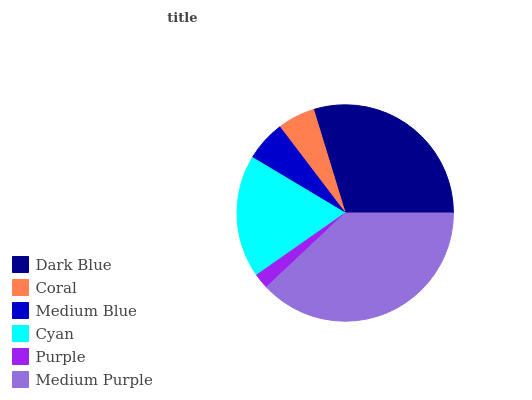Is Purple the minimum?
Answer yes or no. Yes. Is Medium Purple the maximum?
Answer yes or no. Yes. Is Coral the minimum?
Answer yes or no. No. Is Coral the maximum?
Answer yes or no. No. Is Dark Blue greater than Coral?
Answer yes or no. Yes. Is Coral less than Dark Blue?
Answer yes or no. Yes. Is Coral greater than Dark Blue?
Answer yes or no. No. Is Dark Blue less than Coral?
Answer yes or no. No. Is Cyan the high median?
Answer yes or no. Yes. Is Medium Blue the low median?
Answer yes or no. Yes. Is Purple the high median?
Answer yes or no. No. Is Coral the low median?
Answer yes or no. No. 